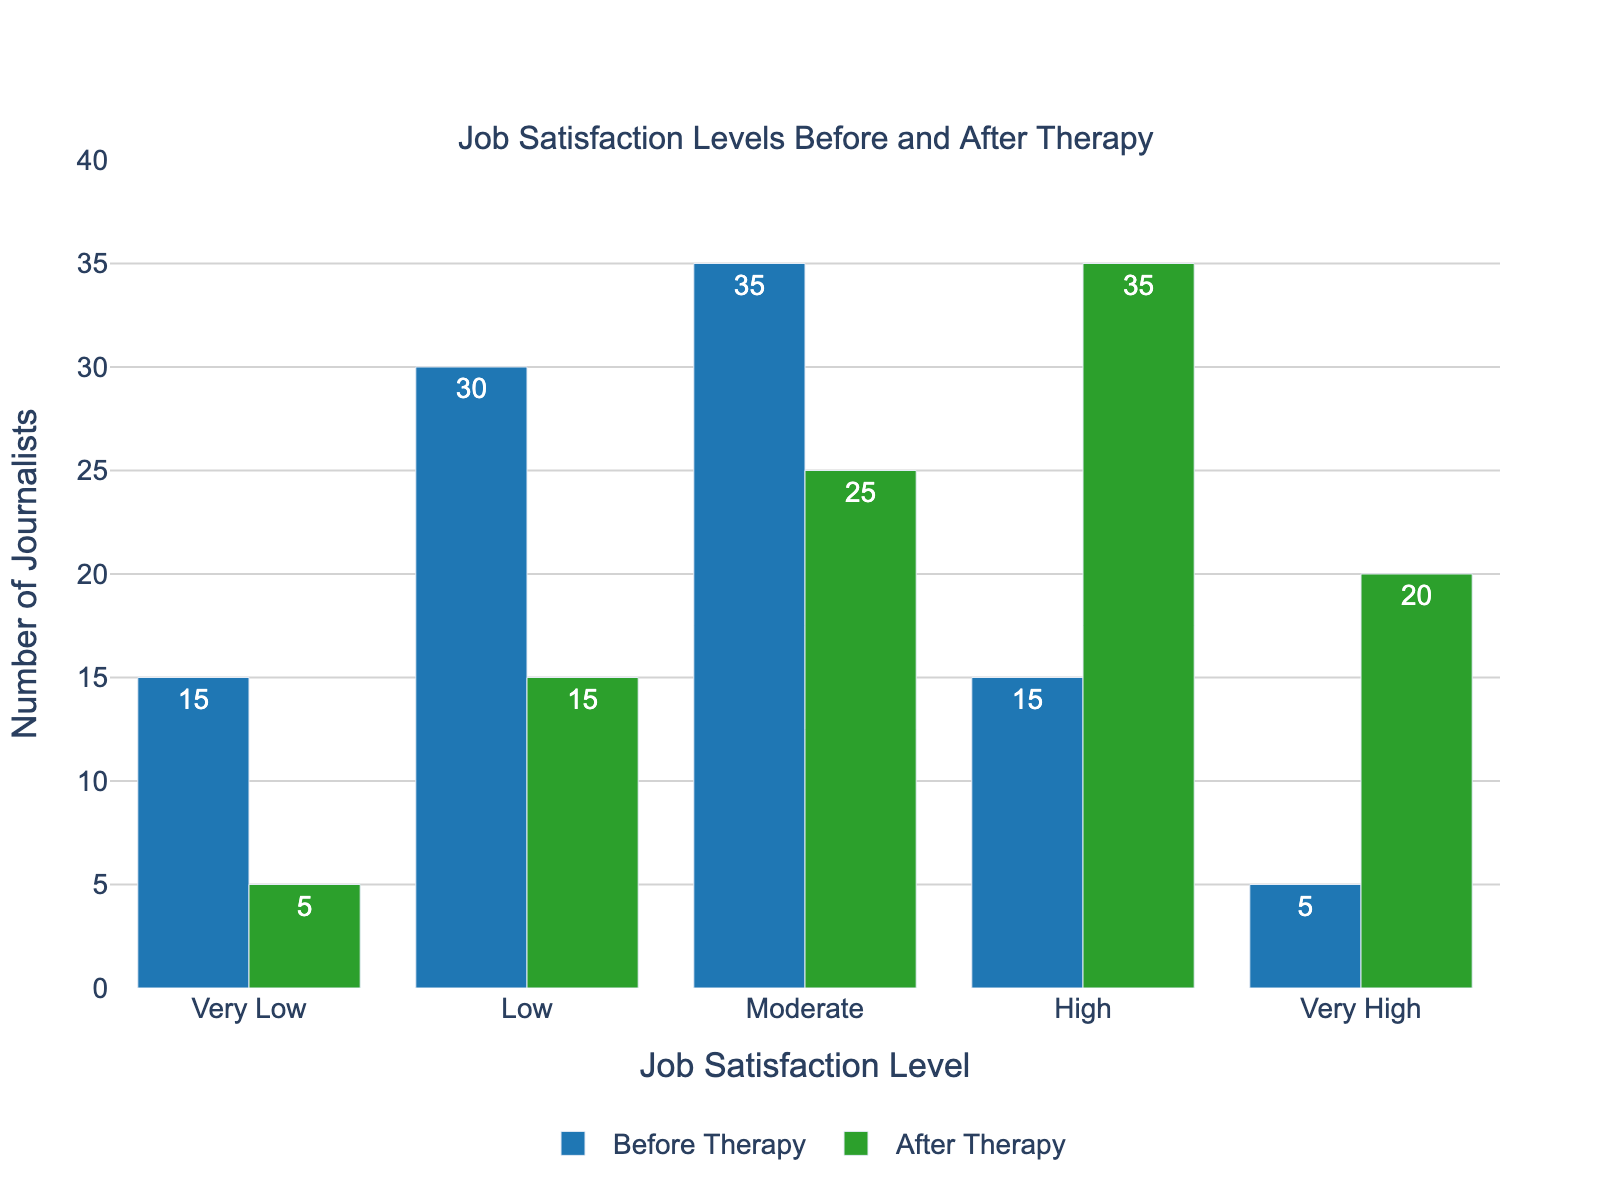What is the difference in the number of journalists with 'Very Low' job satisfaction levels before and after therapy? Before therapy, there were 15 journalists with 'Very Low' job satisfaction levels. After therapy, this number decreased to 5. The difference is 15 - 5 = 10.
Answer: 10 Which job satisfaction level saw the biggest increase after therapy? Compare the 'Before Therapy' and 'After Therapy' numbers for each satisfaction level. 'High' satisfaction levels increased from 15 to 35, and 'Very High' increased from 5 to 20. The largest increase is for 'High', which increased by 20.
Answer: High What is the total number of journalists in the 'Moderate' and 'High' satisfaction levels after therapy? After therapy, the number of journalists with 'Moderate' satisfaction level is 25 and 'High' satisfaction level is 35. Adding these gives 25 + 35 = 60.
Answer: 60 What is the percentage decrease in the number of journalists with 'Low' job satisfaction levels after therapy? Before therapy, there were 30 journalists with 'Low' satisfaction levels, which decreased to 15 after therapy. The decrease is 30 - 15 = 15. The percentage decrease is (15/30) * 100 = 50%.
Answer: 50% Which job satisfaction level experienced the least change after therapy? Comparing all job satisfaction levels, 'Moderate' level changed from 35 to 25, which is a difference of 10. This is the least change among all the levels.
Answer: Moderate How many more journalists have 'Very High' job satisfaction levels after therapy compared to before? Before therapy, there were 5 journalists with 'Very High' job satisfaction levels. After therapy, this number increased to 20. The difference is 20 - 5 = 15.
Answer: 15 Compare the 'Before Therapy' and 'After Therapy' data to determine which satisfaction level had the lowest count before therapy? Analyzing the 'Before Therapy' data, 'Very High' satisfaction level has the lowest count with 5 journalists.
Answer: Very High Calculate the average number of journalists across all job satisfaction levels before therapy. Sum the number of journalists before therapy: 15 + 30 + 35 + 15 + 5 = 100. There are 5 levels, so the average is 100 / 5 = 20.
Answer: 20 